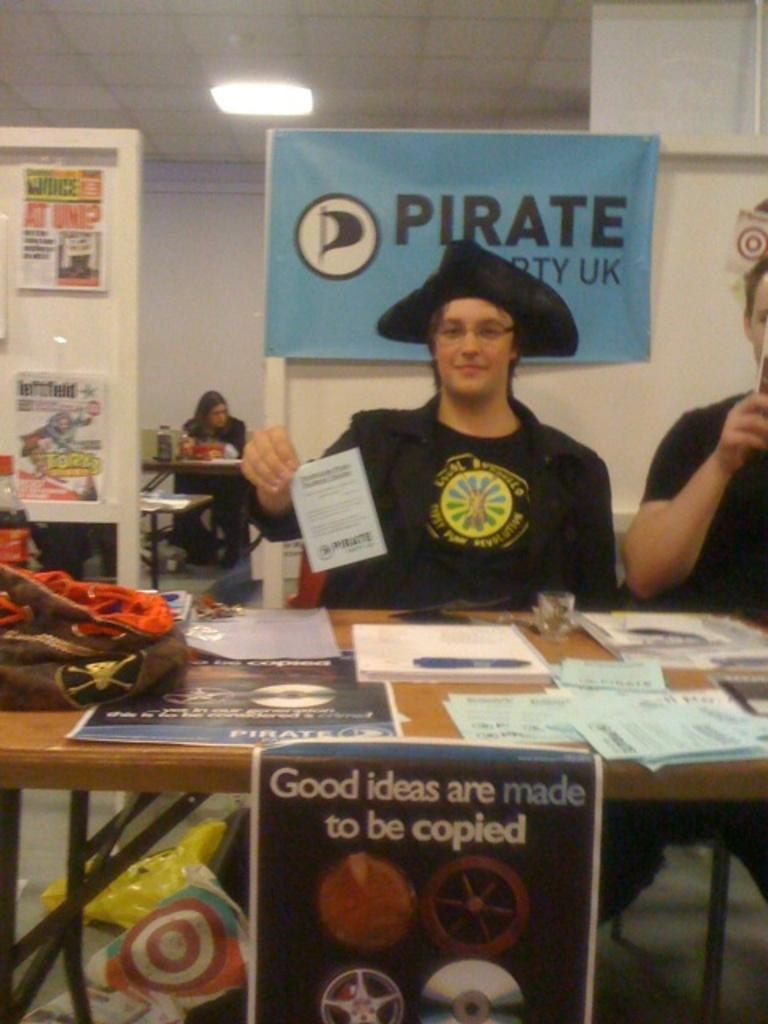<image>
Write a terse but informative summary of the picture. a boy in a pirate hat sitting behind a poster that says 'good ideas are made to be copied' 